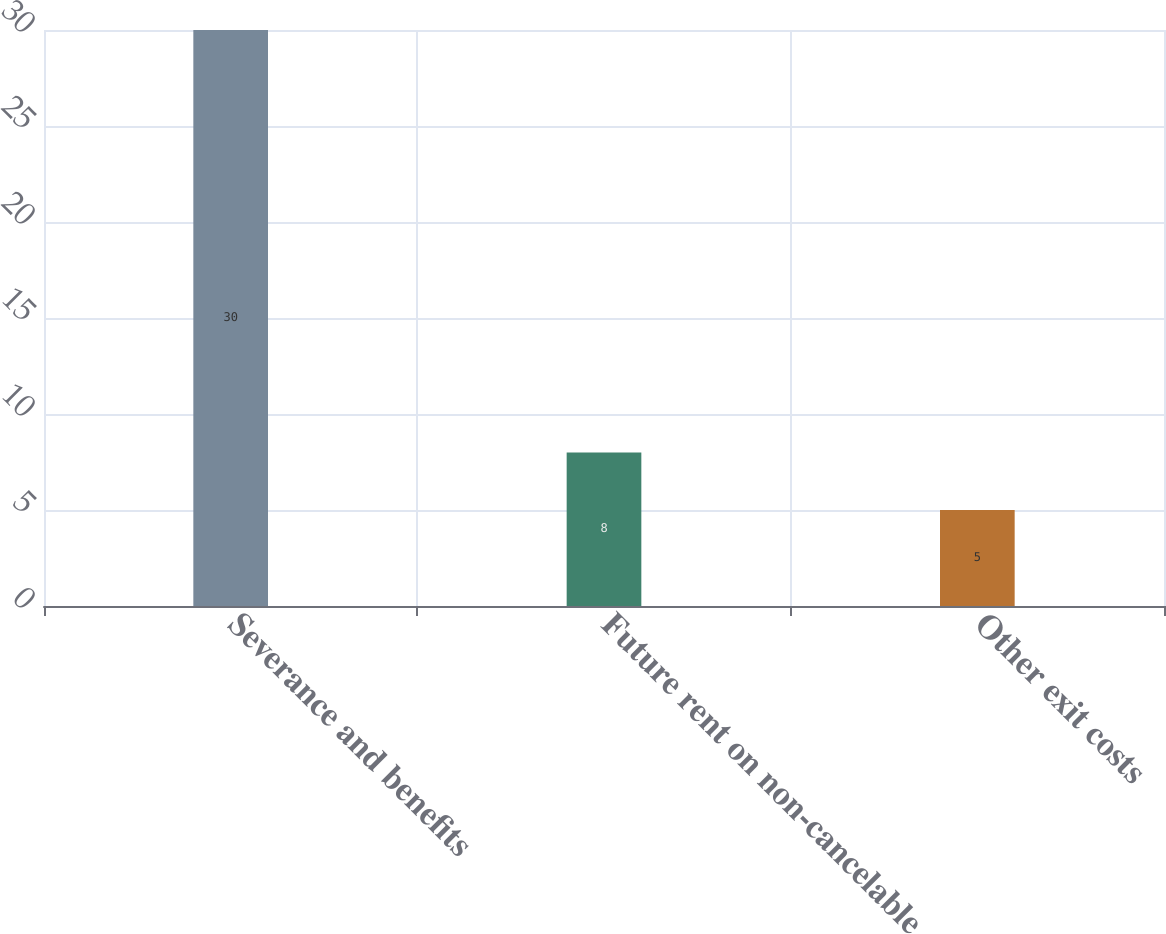Convert chart to OTSL. <chart><loc_0><loc_0><loc_500><loc_500><bar_chart><fcel>Severance and benefits<fcel>Future rent on non-cancelable<fcel>Other exit costs<nl><fcel>30<fcel>8<fcel>5<nl></chart> 